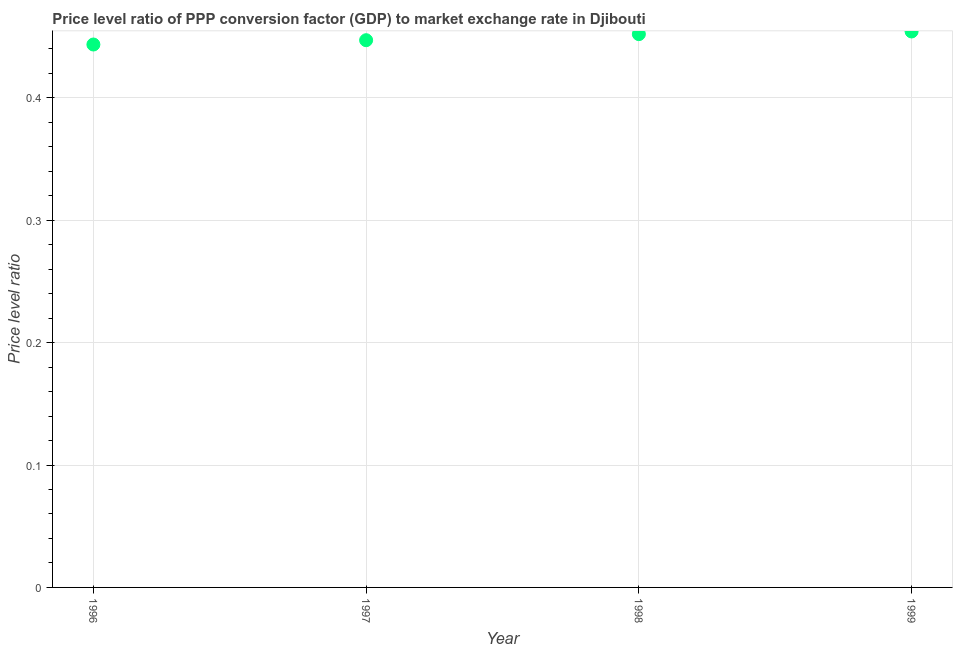What is the price level ratio in 1996?
Offer a very short reply. 0.44. Across all years, what is the maximum price level ratio?
Your answer should be compact. 0.45. Across all years, what is the minimum price level ratio?
Make the answer very short. 0.44. In which year was the price level ratio maximum?
Your answer should be very brief. 1999. What is the sum of the price level ratio?
Your answer should be very brief. 1.8. What is the difference between the price level ratio in 1997 and 1998?
Keep it short and to the point. -0. What is the average price level ratio per year?
Make the answer very short. 0.45. What is the median price level ratio?
Ensure brevity in your answer.  0.45. Do a majority of the years between 1998 and 1996 (inclusive) have price level ratio greater than 0.4 ?
Provide a short and direct response. No. What is the ratio of the price level ratio in 1996 to that in 1999?
Give a very brief answer. 0.98. Is the difference between the price level ratio in 1997 and 1999 greater than the difference between any two years?
Keep it short and to the point. No. What is the difference between the highest and the second highest price level ratio?
Make the answer very short. 0. What is the difference between the highest and the lowest price level ratio?
Make the answer very short. 0.01. In how many years, is the price level ratio greater than the average price level ratio taken over all years?
Make the answer very short. 2. What is the difference between two consecutive major ticks on the Y-axis?
Make the answer very short. 0.1. Are the values on the major ticks of Y-axis written in scientific E-notation?
Give a very brief answer. No. Does the graph contain grids?
Provide a succinct answer. Yes. What is the title of the graph?
Offer a terse response. Price level ratio of PPP conversion factor (GDP) to market exchange rate in Djibouti. What is the label or title of the Y-axis?
Offer a very short reply. Price level ratio. What is the Price level ratio in 1996?
Provide a succinct answer. 0.44. What is the Price level ratio in 1997?
Offer a very short reply. 0.45. What is the Price level ratio in 1998?
Keep it short and to the point. 0.45. What is the Price level ratio in 1999?
Provide a succinct answer. 0.45. What is the difference between the Price level ratio in 1996 and 1997?
Provide a succinct answer. -0. What is the difference between the Price level ratio in 1996 and 1998?
Make the answer very short. -0.01. What is the difference between the Price level ratio in 1996 and 1999?
Give a very brief answer. -0.01. What is the difference between the Price level ratio in 1997 and 1998?
Keep it short and to the point. -0. What is the difference between the Price level ratio in 1997 and 1999?
Keep it short and to the point. -0.01. What is the difference between the Price level ratio in 1998 and 1999?
Your answer should be very brief. -0. What is the ratio of the Price level ratio in 1996 to that in 1998?
Ensure brevity in your answer.  0.98. What is the ratio of the Price level ratio in 1997 to that in 1998?
Give a very brief answer. 0.99. What is the ratio of the Price level ratio in 1997 to that in 1999?
Your answer should be very brief. 0.98. What is the ratio of the Price level ratio in 1998 to that in 1999?
Make the answer very short. 0.99. 